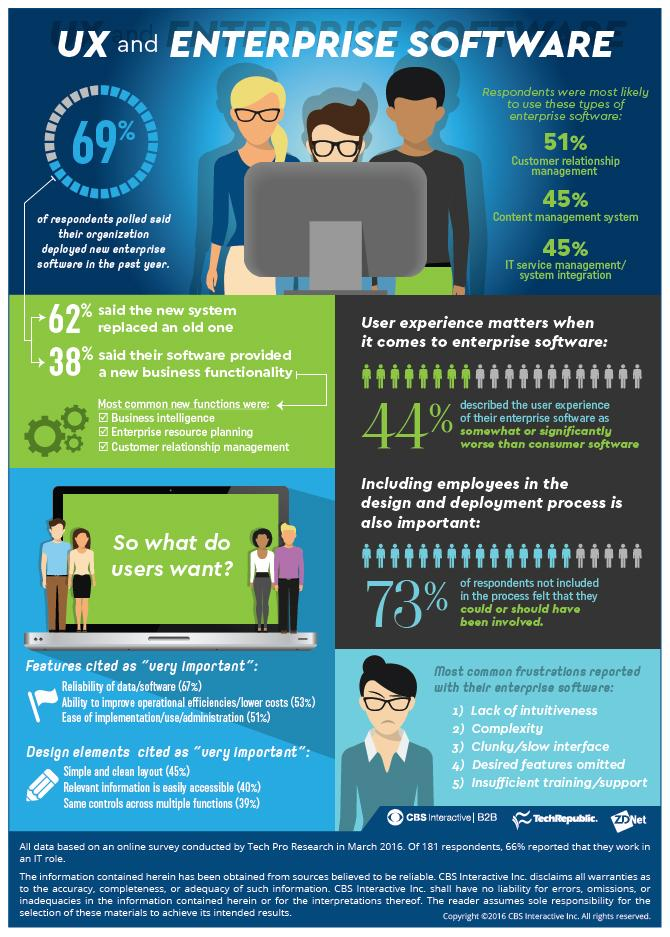Point out several critical features in this image. According to a survey, 51% of people are interested in deploying customer relationship management software. Sixty-two percent of people did not believe that the new software enabled new business functionality. According to the survey, 38% of respondents did not believe that the new system had completely replaced the old one. According to a survey, 44% of employees believe that the new software is significantly better than their company's existing software. 